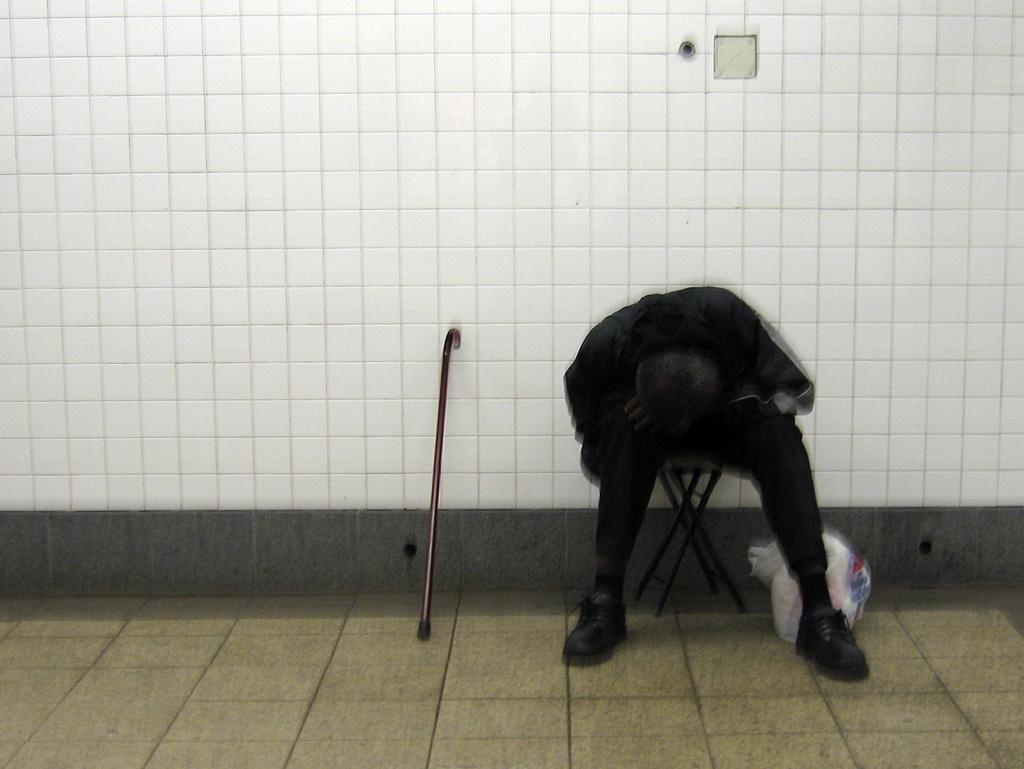What is the person in the image doing? The person is sitting on a chair. What object is near the person? There is a walking stick near the person. What else is near the person? There is a packet near the person. What can be seen in the background of the image? There is a wall in the background. What type of skirt is the person wearing in the image? The image does not show the person wearing a skirt, so it cannot be determined from the image. 